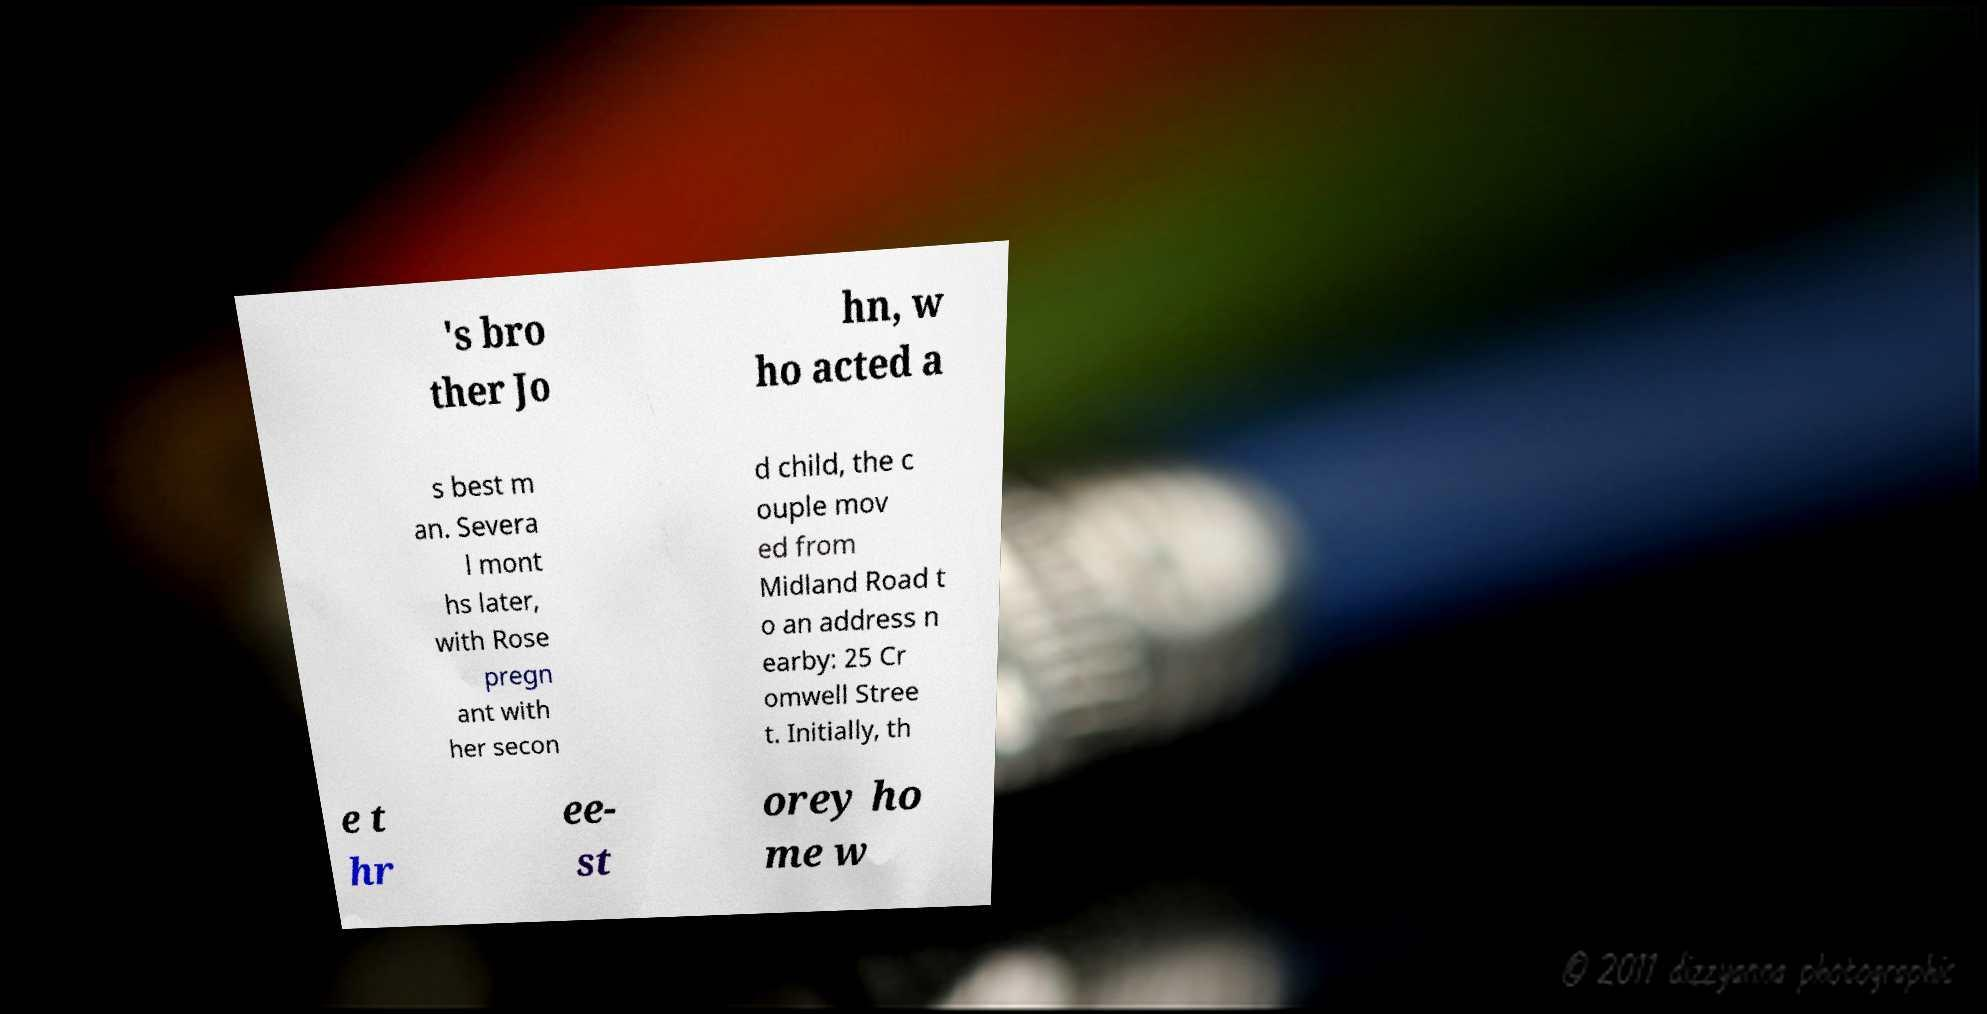What messages or text are displayed in this image? I need them in a readable, typed format. 's bro ther Jo hn, w ho acted a s best m an. Severa l mont hs later, with Rose pregn ant with her secon d child, the c ouple mov ed from Midland Road t o an address n earby: 25 Cr omwell Stree t. Initially, th e t hr ee- st orey ho me w 